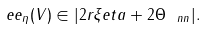<formula> <loc_0><loc_0><loc_500><loc_500>\ e e _ { \eta } ( V ) \in | 2 r \xi e t a + 2 \Theta _ { \ n n } | .</formula> 